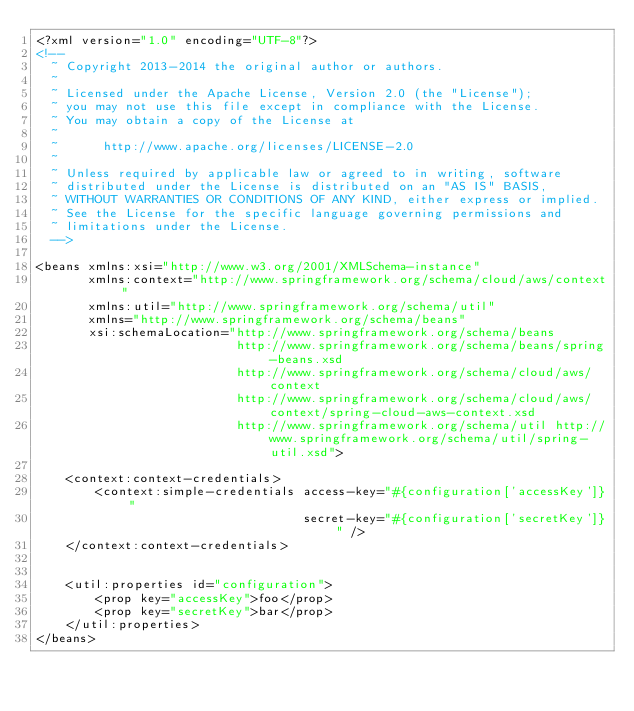Convert code to text. <code><loc_0><loc_0><loc_500><loc_500><_XML_><?xml version="1.0" encoding="UTF-8"?>
<!--
  ~ Copyright 2013-2014 the original author or authors.
  ~
  ~ Licensed under the Apache License, Version 2.0 (the "License");
  ~ you may not use this file except in compliance with the License.
  ~ You may obtain a copy of the License at
  ~
  ~      http://www.apache.org/licenses/LICENSE-2.0
  ~
  ~ Unless required by applicable law or agreed to in writing, software
  ~ distributed under the License is distributed on an "AS IS" BASIS,
  ~ WITHOUT WARRANTIES OR CONDITIONS OF ANY KIND, either express or implied.
  ~ See the License for the specific language governing permissions and
  ~ limitations under the License.
  -->

<beans xmlns:xsi="http://www.w3.org/2001/XMLSchema-instance"
	   xmlns:context="http://www.springframework.org/schema/cloud/aws/context"
	   xmlns:util="http://www.springframework.org/schema/util"
	   xmlns="http://www.springframework.org/schema/beans"
	   xsi:schemaLocation="http://www.springframework.org/schema/beans
	   					   http://www.springframework.org/schema/beans/spring-beans.xsd
	   					   http://www.springframework.org/schema/cloud/aws/context
	   					   http://www.springframework.org/schema/cloud/aws/context/spring-cloud-aws-context.xsd
	   					   http://www.springframework.org/schema/util http://www.springframework.org/schema/util/spring-util.xsd">

	<context:context-credentials>
		<context:simple-credentials access-key="#{configuration['accessKey']}"
									secret-key="#{configuration['secretKey']}" />
	</context:context-credentials>


	<util:properties id="configuration">
		<prop key="accessKey">foo</prop>
		<prop key="secretKey">bar</prop>
	</util:properties>
</beans></code> 